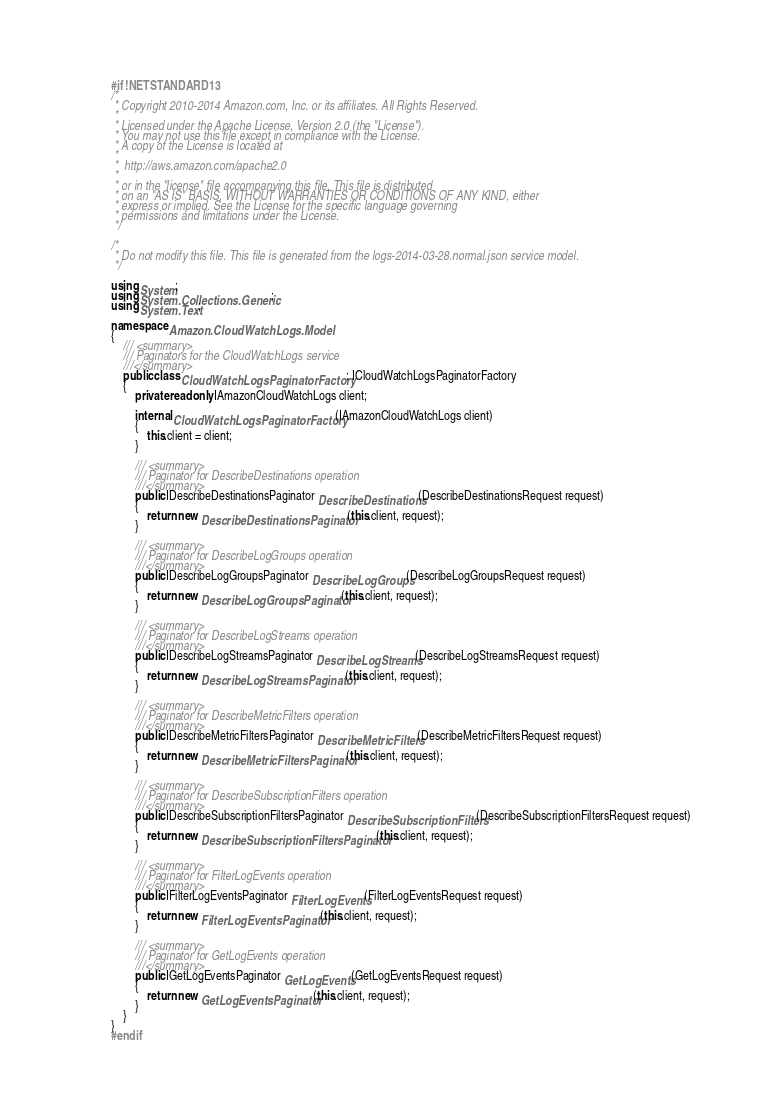Convert code to text. <code><loc_0><loc_0><loc_500><loc_500><_C#_>#if !NETSTANDARD13
/*
 * Copyright 2010-2014 Amazon.com, Inc. or its affiliates. All Rights Reserved.
 * 
 * Licensed under the Apache License, Version 2.0 (the "License").
 * You may not use this file except in compliance with the License.
 * A copy of the License is located at
 * 
 *  http://aws.amazon.com/apache2.0
 * 
 * or in the "license" file accompanying this file. This file is distributed
 * on an "AS IS" BASIS, WITHOUT WARRANTIES OR CONDITIONS OF ANY KIND, either
 * express or implied. See the License for the specific language governing
 * permissions and limitations under the License.
 */

/*
 * Do not modify this file. This file is generated from the logs-2014-03-28.normal.json service model.
 */

using System;
using System.Collections.Generic;
using System.Text;

namespace Amazon.CloudWatchLogs.Model
{
    /// <summary>
    /// Paginators for the CloudWatchLogs service
    ///</summary>
    public class CloudWatchLogsPaginatorFactory : ICloudWatchLogsPaginatorFactory
    {
        private readonly IAmazonCloudWatchLogs client;

        internal CloudWatchLogsPaginatorFactory(IAmazonCloudWatchLogs client) 
        {
            this.client = client;
        }

        /// <summary>
        /// Paginator for DescribeDestinations operation
        ///</summary>
        public IDescribeDestinationsPaginator DescribeDestinations(DescribeDestinationsRequest request) 
        {
            return new DescribeDestinationsPaginator(this.client, request);
        }

        /// <summary>
        /// Paginator for DescribeLogGroups operation
        ///</summary>
        public IDescribeLogGroupsPaginator DescribeLogGroups(DescribeLogGroupsRequest request) 
        {
            return new DescribeLogGroupsPaginator(this.client, request);
        }

        /// <summary>
        /// Paginator for DescribeLogStreams operation
        ///</summary>
        public IDescribeLogStreamsPaginator DescribeLogStreams(DescribeLogStreamsRequest request) 
        {
            return new DescribeLogStreamsPaginator(this.client, request);
        }

        /// <summary>
        /// Paginator for DescribeMetricFilters operation
        ///</summary>
        public IDescribeMetricFiltersPaginator DescribeMetricFilters(DescribeMetricFiltersRequest request) 
        {
            return new DescribeMetricFiltersPaginator(this.client, request);
        }

        /// <summary>
        /// Paginator for DescribeSubscriptionFilters operation
        ///</summary>
        public IDescribeSubscriptionFiltersPaginator DescribeSubscriptionFilters(DescribeSubscriptionFiltersRequest request) 
        {
            return new DescribeSubscriptionFiltersPaginator(this.client, request);
        }

        /// <summary>
        /// Paginator for FilterLogEvents operation
        ///</summary>
        public IFilterLogEventsPaginator FilterLogEvents(FilterLogEventsRequest request) 
        {
            return new FilterLogEventsPaginator(this.client, request);
        }

        /// <summary>
        /// Paginator for GetLogEvents operation
        ///</summary>
        public IGetLogEventsPaginator GetLogEvents(GetLogEventsRequest request) 
        {
            return new GetLogEventsPaginator(this.client, request);
        }
    }
}
#endif</code> 